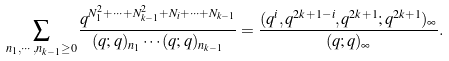<formula> <loc_0><loc_0><loc_500><loc_500>\sum _ { n _ { 1 } , \cdots , n _ { k - 1 } \geq 0 } \frac { q ^ { N _ { 1 } ^ { 2 } + \cdots + N _ { k - 1 } ^ { 2 } + N _ { i } + \cdots + N _ { k - 1 } } } { ( q ; q ) _ { n _ { 1 } } \cdots ( q ; q ) _ { n _ { k - 1 } } } = \frac { ( q ^ { i } , q ^ { 2 k + 1 - i } , q ^ { 2 k + 1 } ; q ^ { 2 k + 1 } ) _ { \infty } } { ( q ; q ) _ { \infty } } .</formula> 